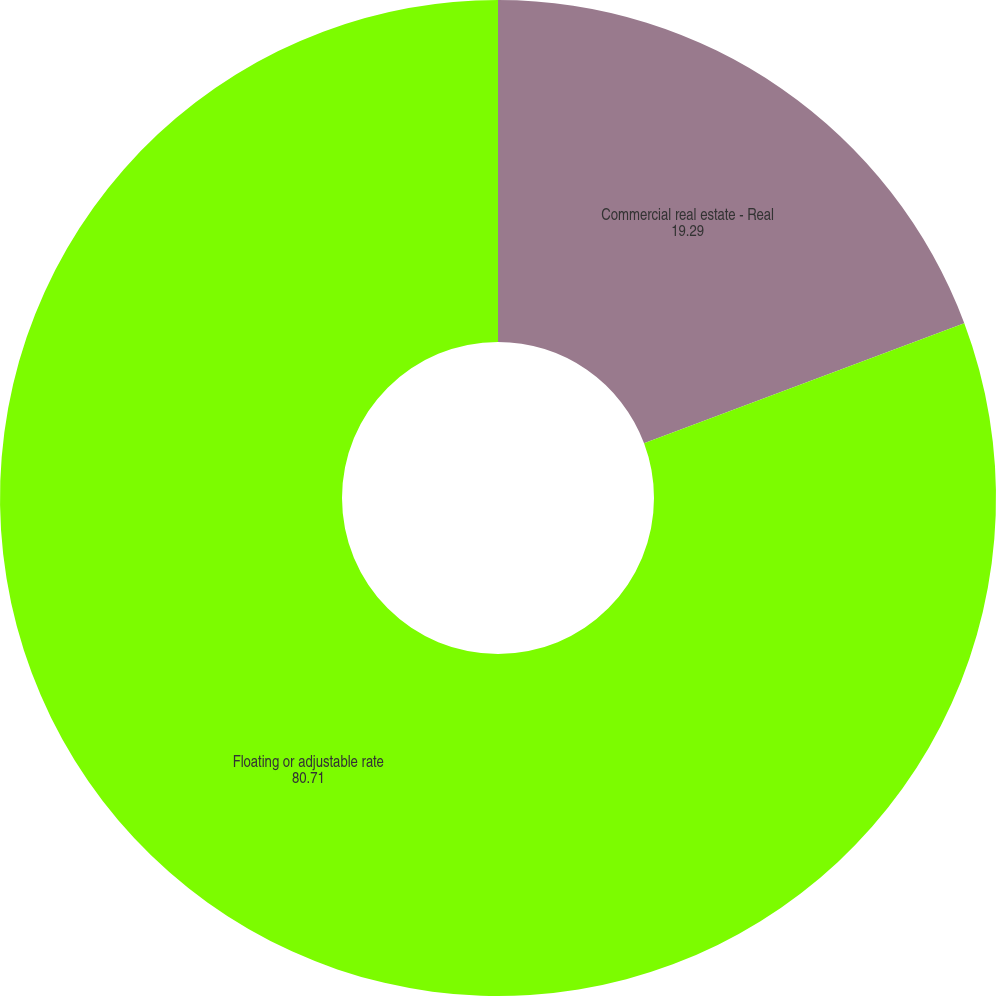Convert chart. <chart><loc_0><loc_0><loc_500><loc_500><pie_chart><fcel>Commercial real estate - Real<fcel>Floating or adjustable rate<nl><fcel>19.29%<fcel>80.71%<nl></chart> 